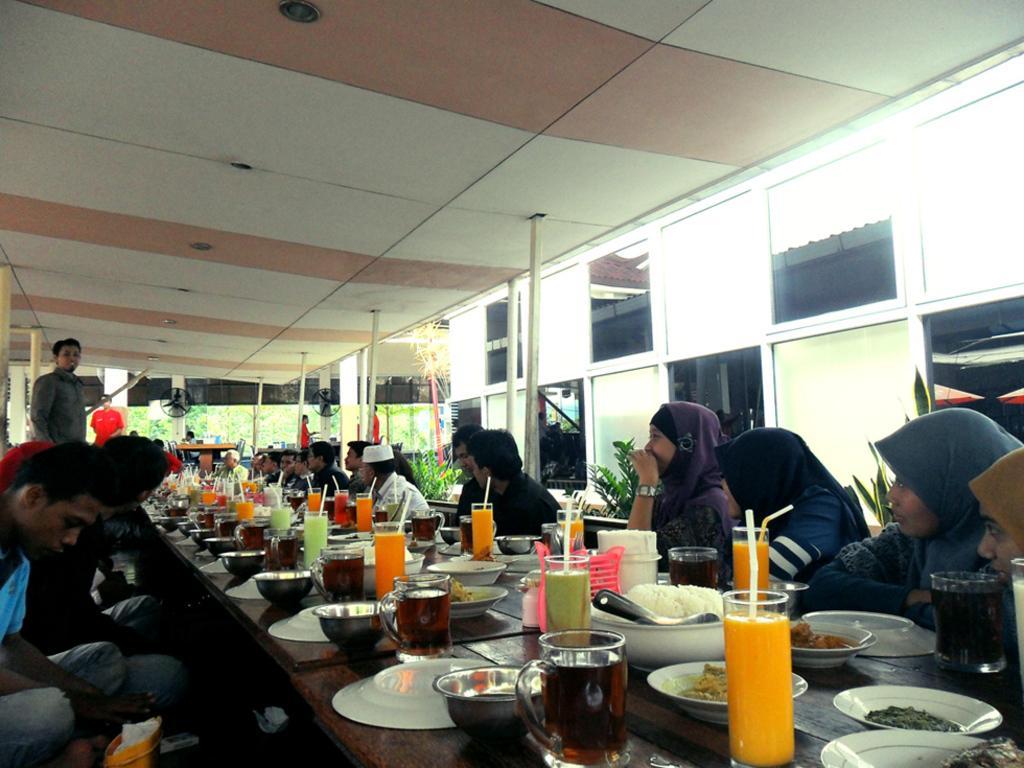How would you summarize this image in a sentence or two? Group of people sitting and These persons are standing. We can see glasses with drinks,Bowls,plates,food,spoons on the table. On the background we can see glass windows. On the top we can see lights. 